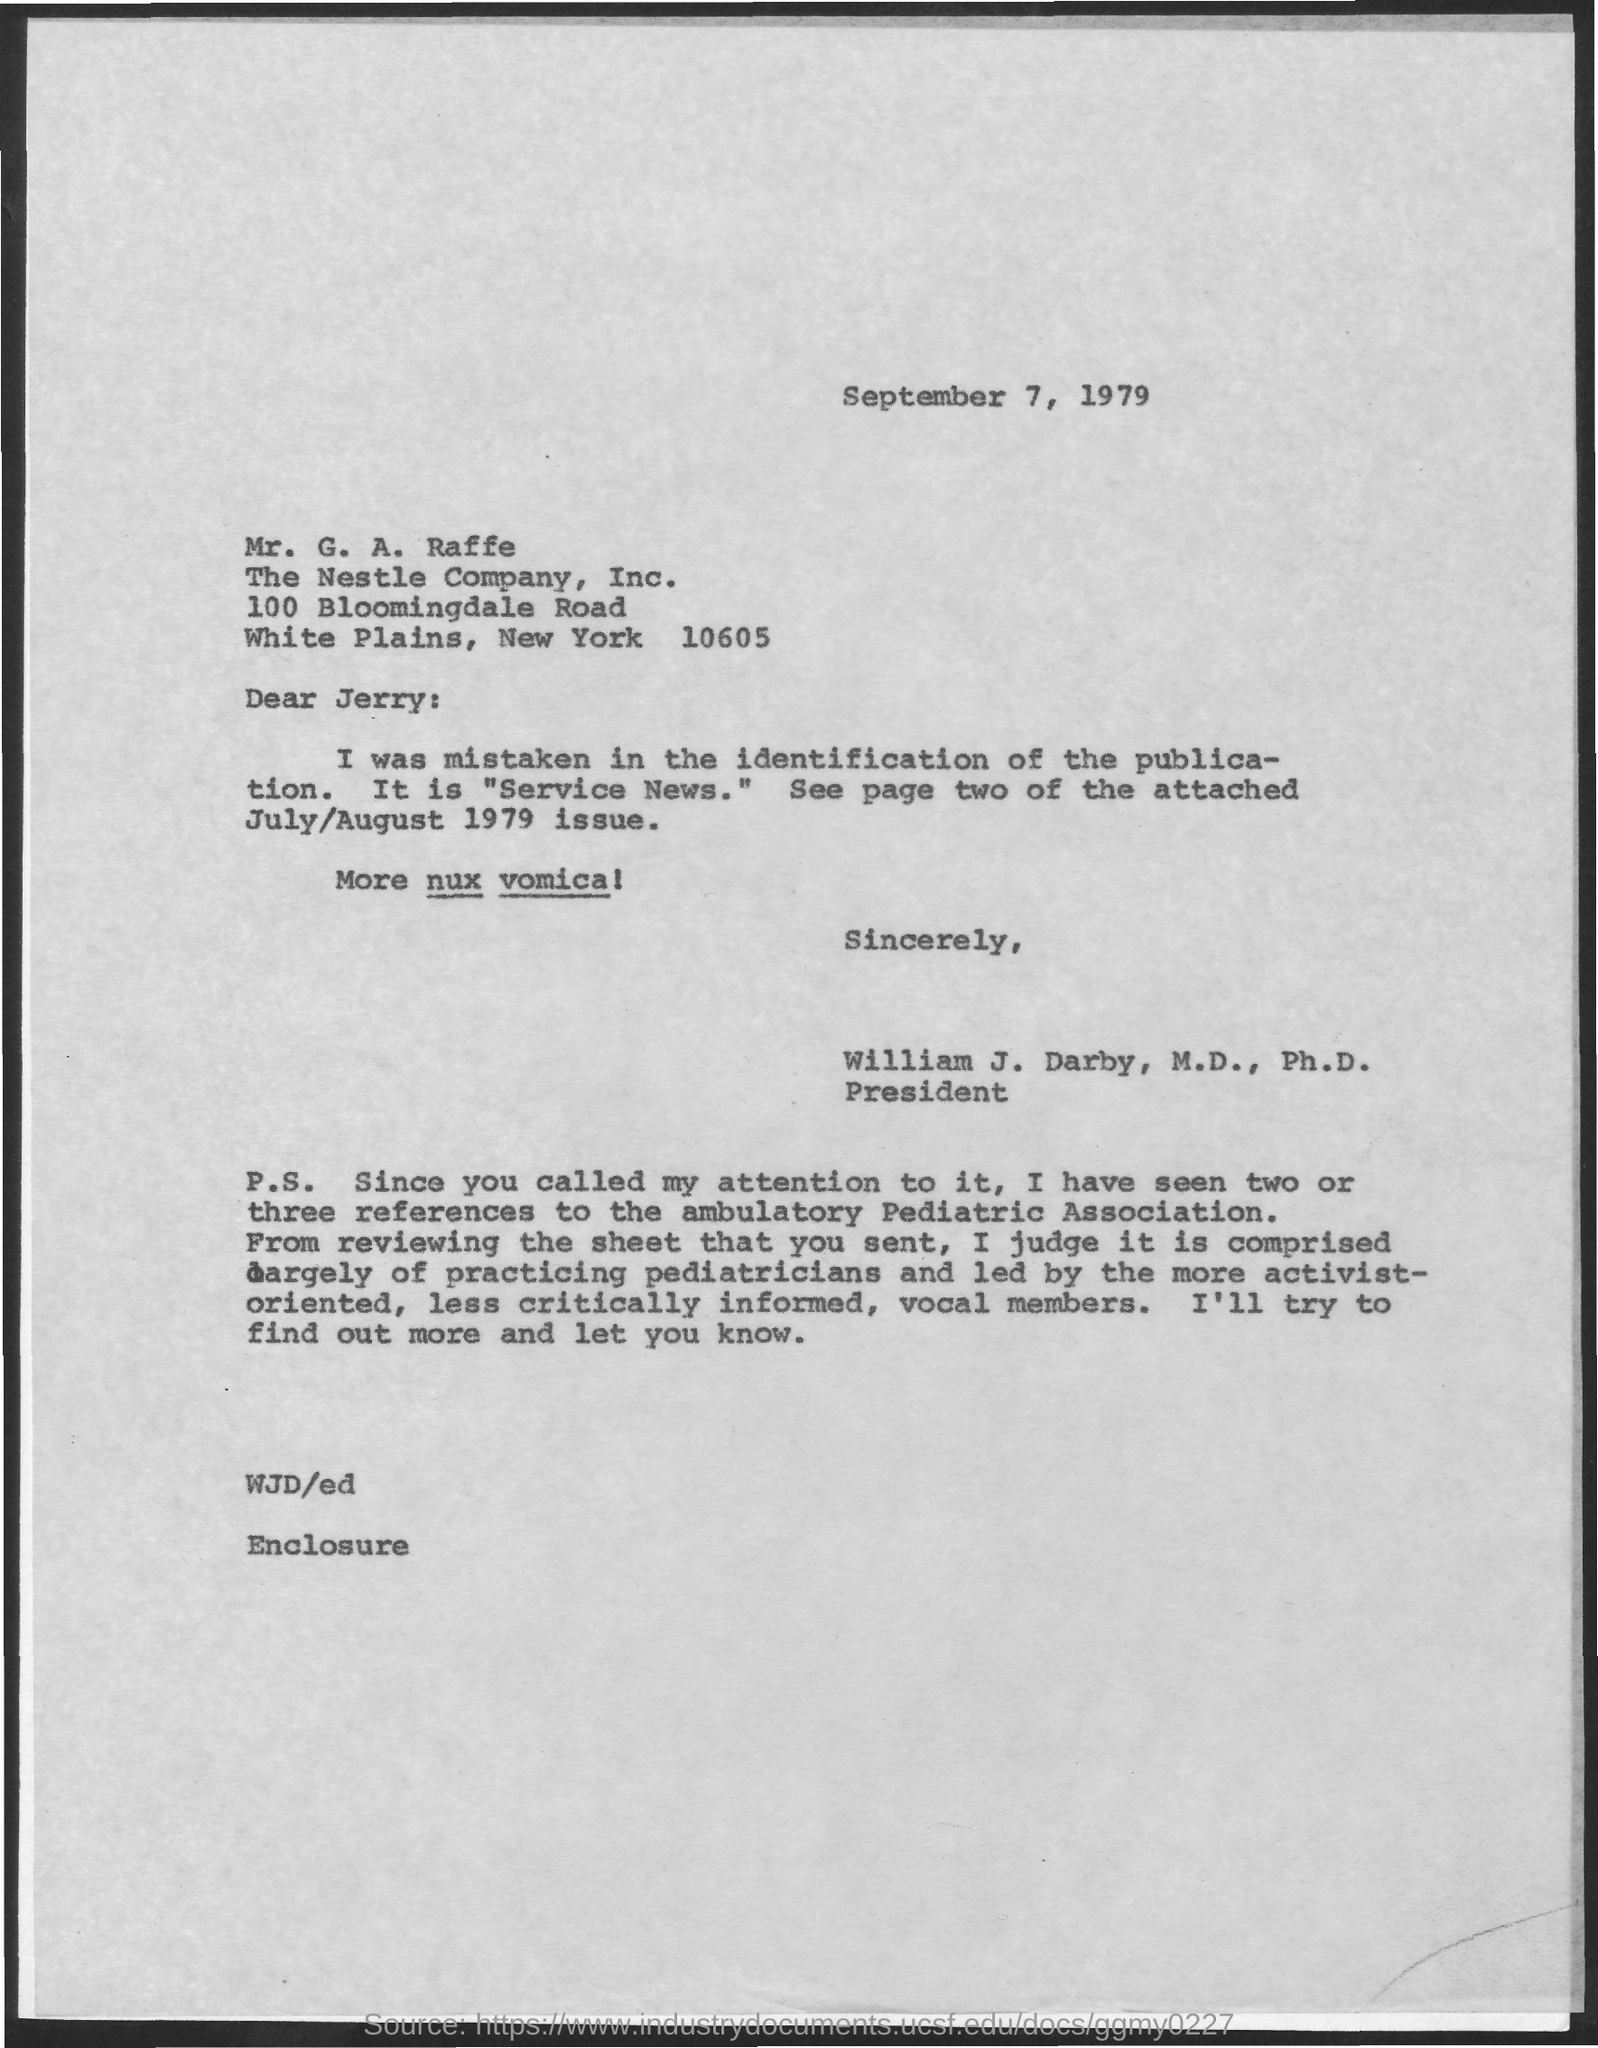Point out several critical features in this image. This letter is addressed to Mr. G. A. Raffe. 